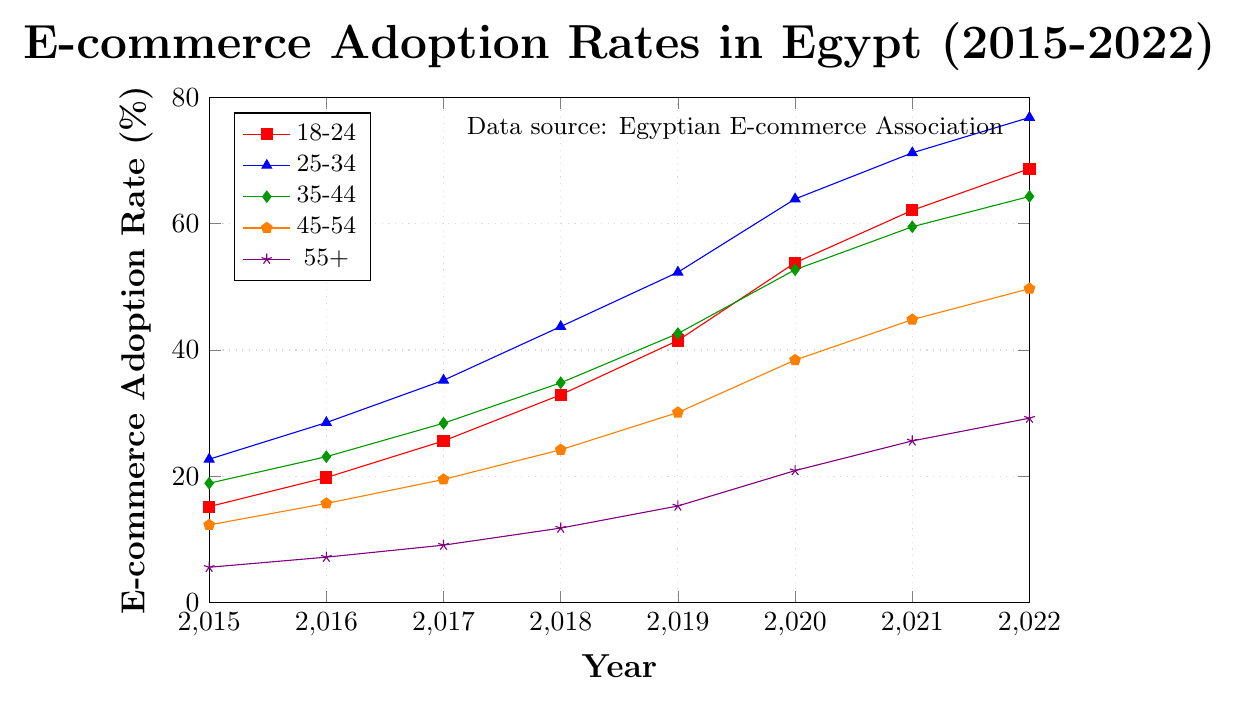What is the E-commerce adoption rate for the 25-34 age group in 2020? Look at the point on the line representing the 25-34 age group in 2020 on the x-axis. The y-value for this point is the adoption rate.
Answer: 63.9% Which age group had the lowest E-commerce adoption rate in 2022? Compare the y-values of all lines at the year 2022 on the x-axis. The line with the smallest y-value represents the age group with the lowest adoption rate.
Answer: 55+ How much did the E-commerce adoption rate increase for the 35-44 age group from 2015 to 2022? Find the y-values for the 35-44 age group in 2015 and 2022, then subtract the 2015 value from the 2022 value: 64.3 - 18.9.
Answer: 45.4% What is the difference in the E-commerce adoption rate between the 25-34 and 45-54 age groups in 2018? Look at the y-values for the 25-34 and 45-54 age groups in 2018. Subtract the 45-54 value from the 25-34 value: 43.7 - 24.2.
Answer: 19.5% Between which two consecutive years did the 18-24 age group see the highest increase in E-commerce adoption rates? Calculate the annual increases for the 18-24 age group between consecutive years and compare: 2016-2015 (19.8-15.2=4.6), 2017-2016 (25.6-19.8=5.8), 2018-2017 (32.9-25.6=7.3), 2019-2018 (41.5-32.9=8.6), 2020-2019 (53.8-41.5=12.3), 2021-2020 (62.1-53.8=8.3), 2022-2021 (68.7-62.1=6.6). The highest increase is between 2019 and 2020.
Answer: 2019 and 2020 How did the adoption rate of the 55+ age group in 2022 compare to its rate in 2015? Look at the y-values for the 55+ age group in 2015 and 2022. Note the significant increase: from 5.6 in 2015 to 29.2 in 2022.
Answer: Increased significantly What is the average adoption rate for the 45-54 age group from 2015 to 2022? Add the y-values for the 45-54 group from 2015 to 2022 and divide by the number of years: (12.3 + 15.7 + 19.5 + 24.2 + 30.1 + 38.4 + 44.8 + 49.7) / 8. The sum is 234.7, so the average is 234.7 / 8.
Answer: 29.34% Which age group had the highest E-commerce adoption rate in 2019? Compare the y-values of all age groups for the year 2019. The 25-34 age group has the highest y-value at 52.3.
Answer: 25-34 